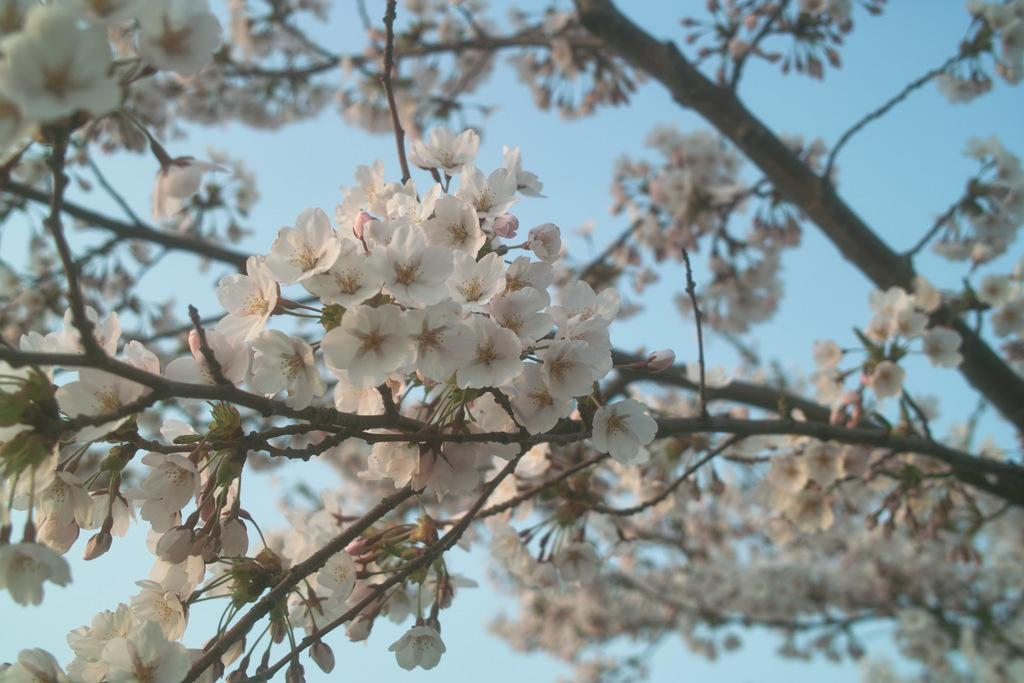What type of flowers are on the tree in the image? There are white color flowers on a tree in the image. What can be seen in the background of the image? The sky is visible in the background of the image. How many snakes are crawling on the tree in the image? There are no snakes present in the image; it only features a tree with white flowers. 